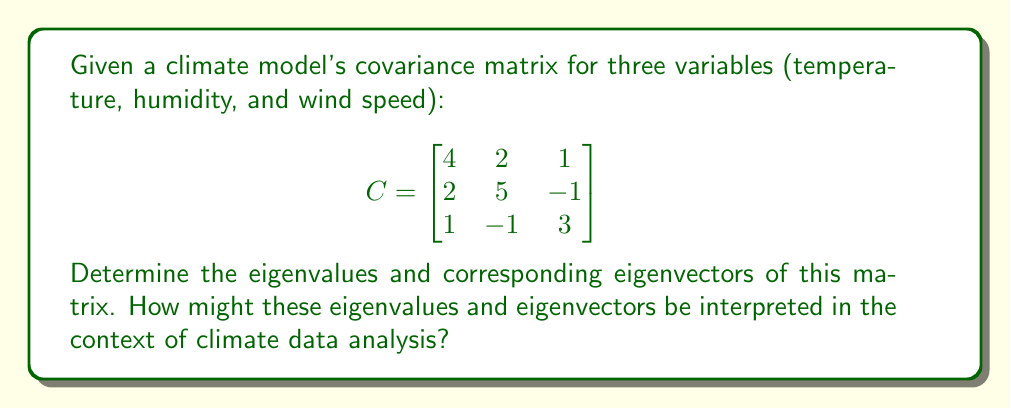Can you answer this question? To find the eigenvalues and eigenvectors of the covariance matrix, we follow these steps:

1) First, we find the eigenvalues by solving the characteristic equation:
   $$det(C - \lambda I) = 0$$

   Expanding this:
   $$\begin{vmatrix}
   4-\lambda & 2 & 1 \\
   2 & 5-\lambda & -1 \\
   1 & -1 & 3-\lambda
   \end{vmatrix} = 0$$

   $$(4-\lambda)(5-\lambda)(3-\lambda) + 2(-1) + 1(2) - (4-\lambda)(-1) - (5-\lambda)(1) - (3-\lambda)(2) = 0$$

   Simplifying:
   $$-\lambda^3 + 12\lambda^2 - 41\lambda + 38 = 0$$

2) Solving this cubic equation (using a computer algebra system or numerical methods), we get the eigenvalues:
   $$\lambda_1 \approx 7.54, \lambda_2 \approx 3.13, \lambda_3 \approx 1.33$$

3) For each eigenvalue, we find the corresponding eigenvector by solving:
   $$(C - \lambda_i I)\mathbf{v}_i = \mathbf{0}$$

4) For $\lambda_1 \approx 7.54$:
   $$\begin{bmatrix}
   -3.54 & 2 & 1 \\
   2 & -2.54 & -1 \\
   1 & -1 & -4.54
   \end{bmatrix}\mathbf{v}_1 = \mathbf{0}$$

   Solving this system (and normalizing), we get:
   $$\mathbf{v}_1 \approx (0.62, 0.74, 0.25)^T$$

5) Similarly, for $\lambda_2 \approx 3.13$ and $\lambda_3 \approx 1.33$, we get:
   $$\mathbf{v}_2 \approx (-0.37, 0.25, 0.89)^T$$
   $$\mathbf{v}_3 \approx (0.69, -0.62, 0.37)^T$$

Interpretation: In climate data analysis, the eigenvalues represent the amount of variance explained by each principal component, while the eigenvectors represent the directions of these components in the original variable space. The largest eigenvalue ($\lambda_1$) corresponds to the direction of maximum variance in the data, which might represent a dominant climate pattern. The corresponding eigenvector shows how each original variable contributes to this pattern. Smaller eigenvalues represent less significant patterns or potentially noise in the data.
Answer: Eigenvalues: $\lambda_1 \approx 7.54, \lambda_2 \approx 3.13, \lambda_3 \approx 1.33$

Eigenvectors:
$\mathbf{v}_1 \approx (0.62, 0.74, 0.25)^T$
$\mathbf{v}_2 \approx (-0.37, 0.25, 0.89)^T$
$\mathbf{v}_3 \approx (0.69, -0.62, 0.37)^T$ 